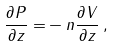Convert formula to latex. <formula><loc_0><loc_0><loc_500><loc_500>\frac { \partial P } { \partial z } = & - n \frac { \partial V } { \partial z } \, ,</formula> 